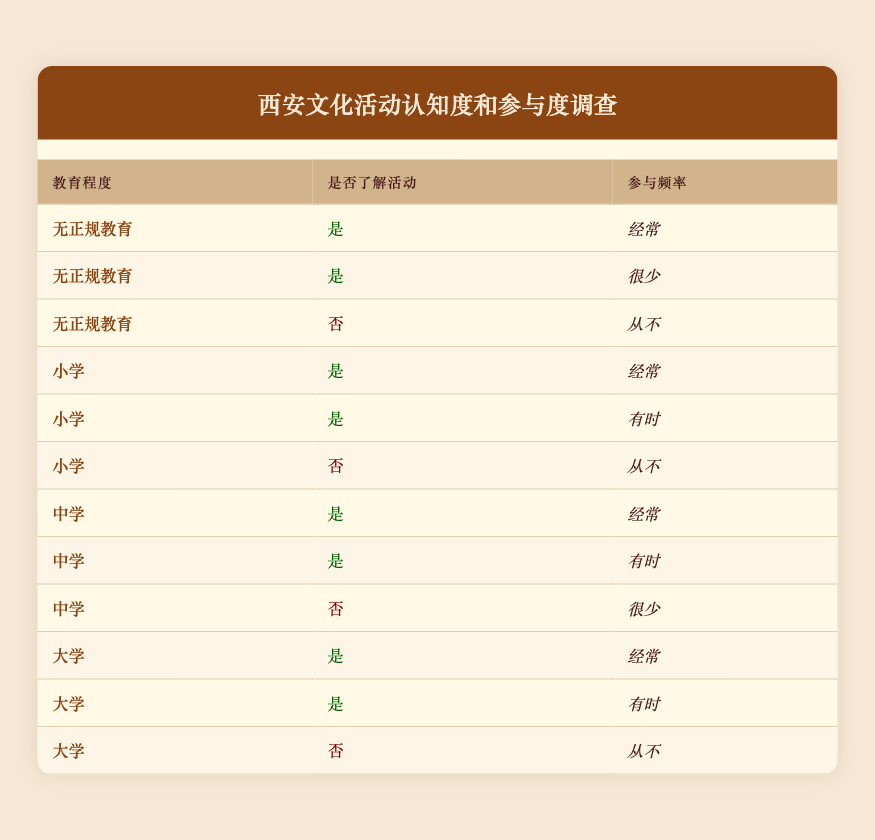What is the total number of respondents with no formal education who are aware of cultural events? There are three entries for "No formal education." Two of them have "Yes" for awareness of events, so we count them: 2.
Answer: 2 How many respondents with a primary school education never use cultural events? For primary school education, there is one entry with "No" for awareness of events and "Never" for usage, which counts as 1 participant.
Answer: 1 What percentage of university-educated respondents are often aware of cultural events? There are three entries for university education. Out of these, two respondents are "Yes" for awareness and "Often" for usage. To get the percentage, we do (2 / 3) * 100 = 66.67%.
Answer: 66.67 Are there any respondents with secondary school education who are unaware of cultural events? There is one entry for secondary school education where the respondent is "No" for awareness of events, confirming that there is indeed a respondent who is unaware of cultural events.
Answer: Yes How many respondents are often aware of cultural events across all education levels? We can add up the entries for each education level where awareness is "Yes" and usage is "Often": 1 (No formal) + 1 (Primary) + 1 (Secondary) + 1 (University) = 4 respondents are often aware of cultural events.
Answer: 4 What is the difference in awareness between respondents with secondary school education and those with university education who are unaware of cultural events? Looking at the table, there is one respondent with secondary school education who is "No" aware, and one with university education who is also "No" aware. Both groups have 1 respondent, so the difference is 0.
Answer: 0 How many total respondents are there with awareness of events who use them sometimes? There are three instances where the awareness is "Yes" and usage is "Sometimes," from primary (1), secondary (1), and university (1) education levels, totaling 3.
Answer: 3 Are there more respondents with primary school education who are aware of events compared to those with no formal education? There are three respondents with primary education who are "Yes" aware vs. two with no formal education. Since 3 is more than 2, the answer is yes.
Answer: Yes What is the most common usage frequency among all respondents who are aware of cultural events? We have to look through the entries where awareness is "Yes." Counting the frequencies, the majority across all education levels who answered "Often" totals to 5, while "Sometimes" has 3. Thus, "Often" is the most common frequency.
Answer: Often 